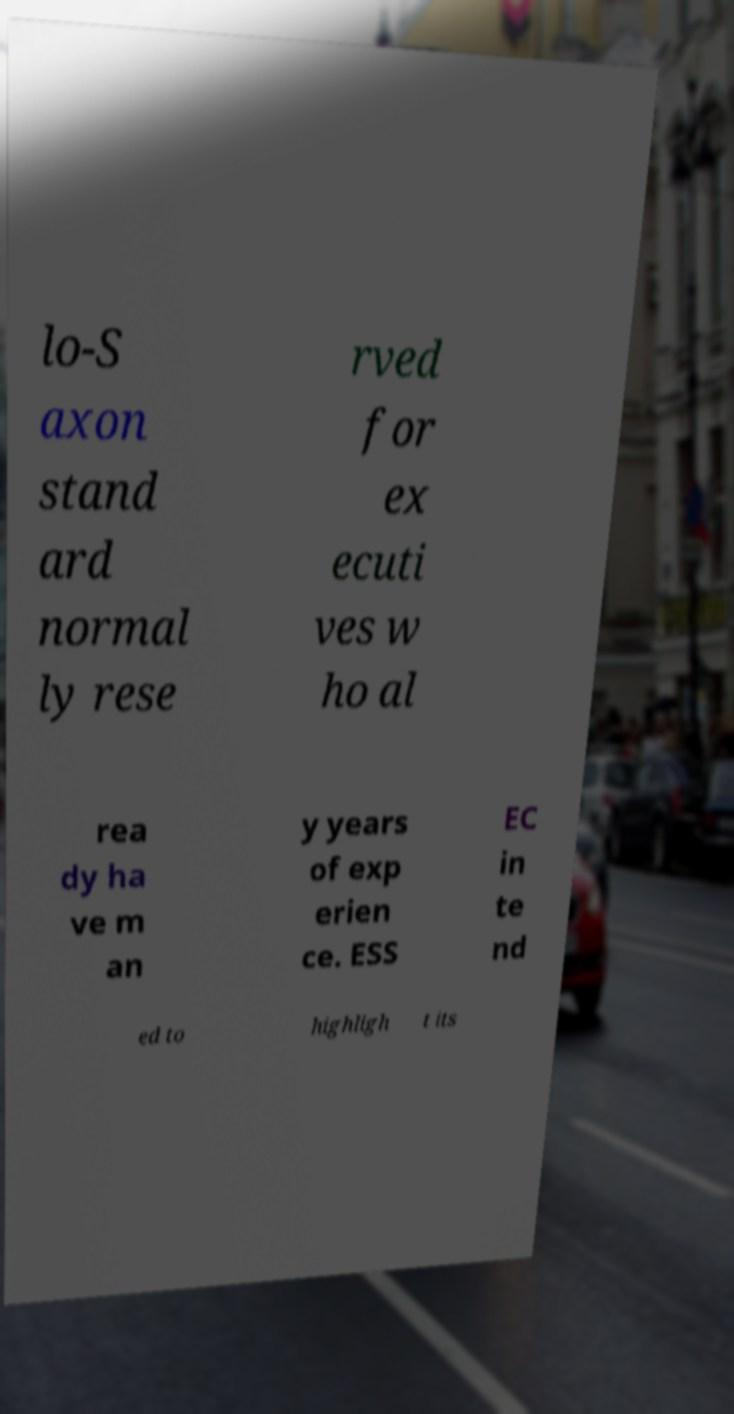What kind of document does this text appear to be from, and what could be its purpose based on the visible text? Based on the fragmented text visible in the image, it looks like it might be from a corporate or educational brochure, possibly a part of a presentation or a promotional material. The text seems to address a higher standard or expectations, possibly aiming to highlight the qualifications or benefits of a service or program designed for seasoned executives. The intent might be to attract a specific audience looking for advanced opportunities or exclusive services.  Can you make out any details about the location or setting where this document might be used from the visible parts of the image? While the text itself does not provide explicit details about the location or specific use setting, the style of the document and the context suggested by the text imply a professional or academic setting. Based on the segments indicating exclusivity and experience, this could be at a corporate event, a seminar, or possibly at an institution like ESSEC that seems to be mentioned, designed to appeal to professionals seeking to enrich their careers. 